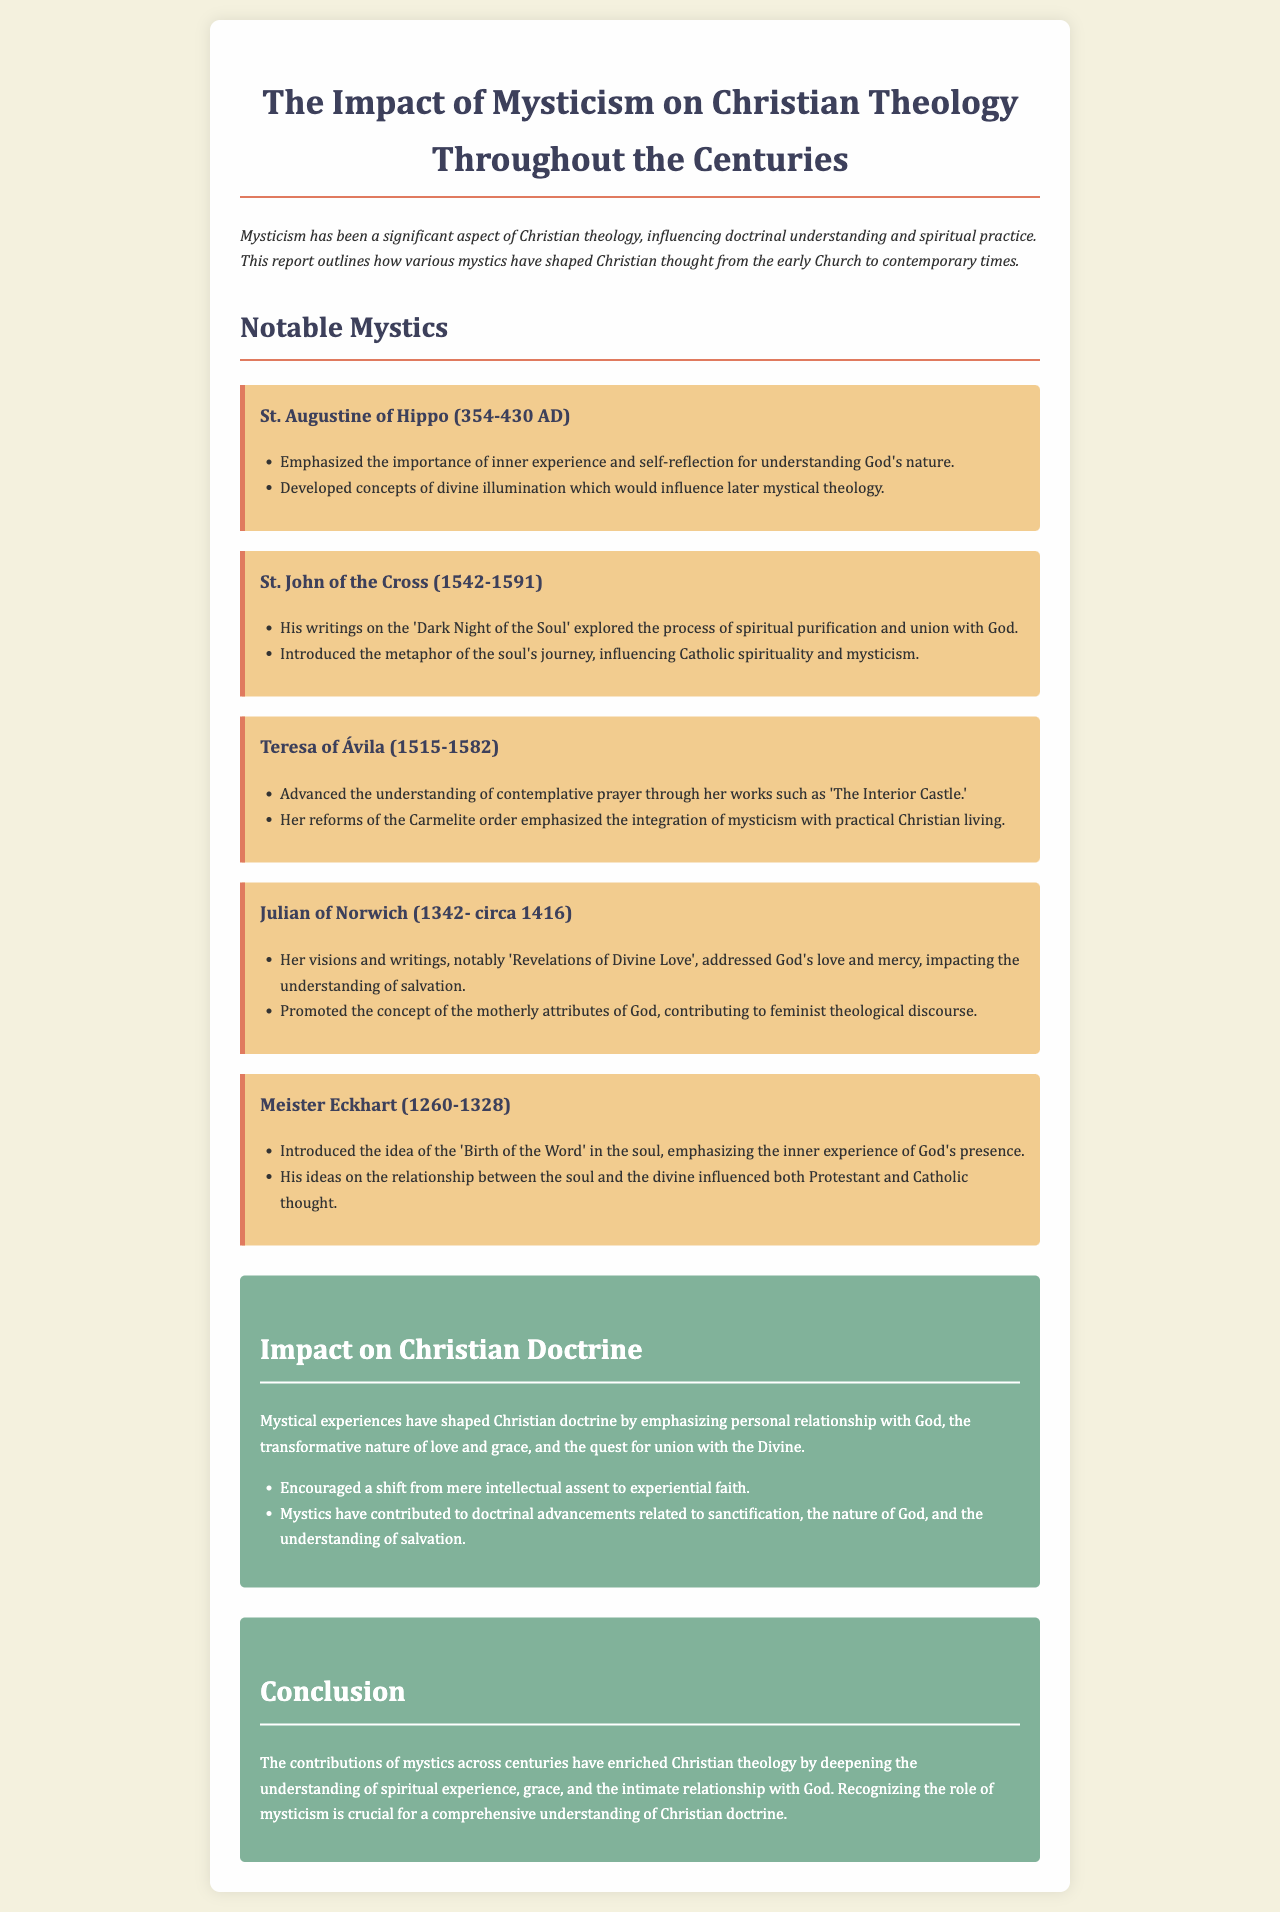What is the title of the report? The title of the report is found in the heading of the document.
Answer: The Impact of Mysticism on Christian Theology Throughout the Centuries Who wrote 'Revelations of Divine Love'? This information is provided in the section detailing notable mystics.
Answer: Julian of Norwich What significant concept did Meister Eckhart introduce? The document states that he introduced a specific idea related to the soul and God’s presence.
Answer: Birth of the Word In what year was St. John of the Cross born? The document provides the birth year of St. John of the Cross.
Answer: 1542 Which mystic emphasized the integration of mysticism with practical Christian living? The notable contributions of a specific mystic to practical living are mentioned in the report.
Answer: Teresa of Ávila How did mystics influence the understanding of salvation? The report discusses the contributions of mystics to this doctrinal aspect under impact.
Answer: Addressed God's love and mercy What does the report suggest has been encouraged by mystical experiences? The document outlines a shift mentioned under the impact on Christian doctrine.
Answer: Experiential faith What period does St. Augustine of Hippo belong to? The report indicates the time frame for St. Augustine of Hippo in his introduction.
Answer: Early Church 